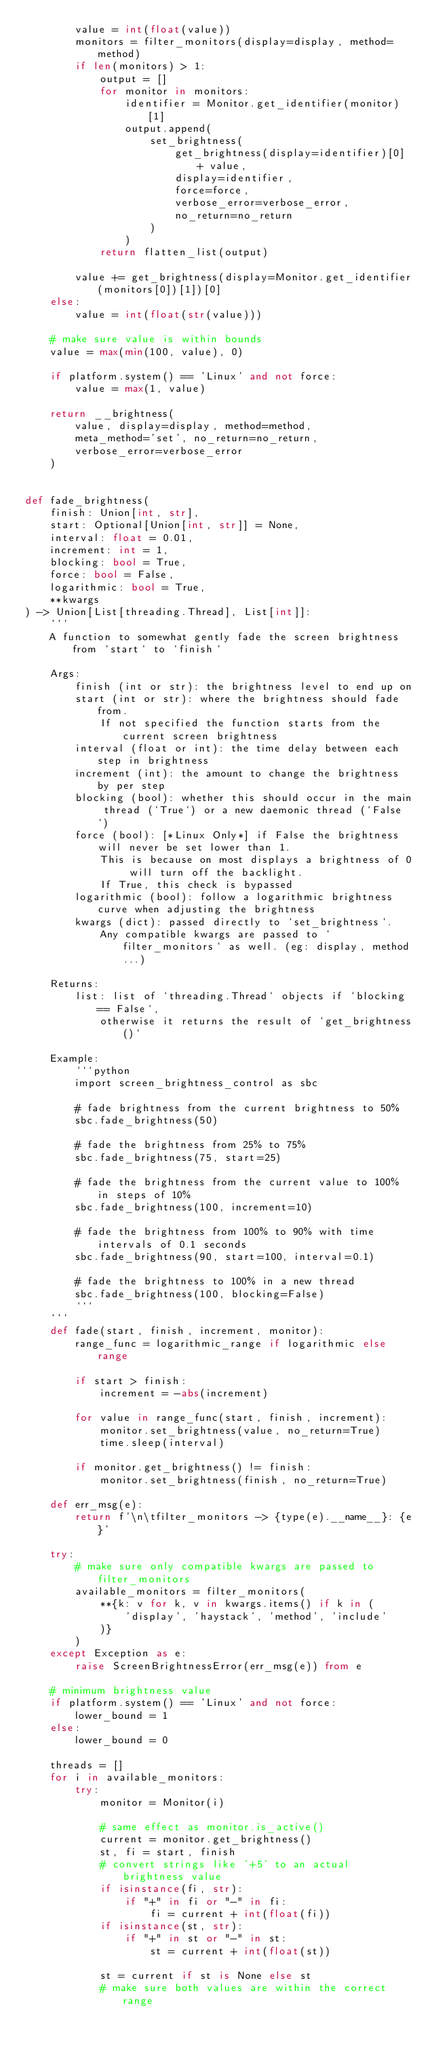<code> <loc_0><loc_0><loc_500><loc_500><_Python_>        value = int(float(value))
        monitors = filter_monitors(display=display, method=method)
        if len(monitors) > 1:
            output = []
            for monitor in monitors:
                identifier = Monitor.get_identifier(monitor)[1]
                output.append(
                    set_brightness(
                        get_brightness(display=identifier)[0] + value,
                        display=identifier,
                        force=force,
                        verbose_error=verbose_error,
                        no_return=no_return
                    )
                )
            return flatten_list(output)

        value += get_brightness(display=Monitor.get_identifier(monitors[0])[1])[0]
    else:
        value = int(float(str(value)))

    # make sure value is within bounds
    value = max(min(100, value), 0)

    if platform.system() == 'Linux' and not force:
        value = max(1, value)

    return __brightness(
        value, display=display, method=method,
        meta_method='set', no_return=no_return,
        verbose_error=verbose_error
    )


def fade_brightness(
    finish: Union[int, str],
    start: Optional[Union[int, str]] = None,
    interval: float = 0.01,
    increment: int = 1,
    blocking: bool = True,
    force: bool = False,
    logarithmic: bool = True,
    **kwargs
) -> Union[List[threading.Thread], List[int]]:
    '''
    A function to somewhat gently fade the screen brightness from `start` to `finish`

    Args:
        finish (int or str): the brightness level to end up on
        start (int or str): where the brightness should fade from.
            If not specified the function starts from the current screen brightness
        interval (float or int): the time delay between each step in brightness
        increment (int): the amount to change the brightness by per step
        blocking (bool): whether this should occur in the main thread (`True`) or a new daemonic thread (`False`)
        force (bool): [*Linux Only*] if False the brightness will never be set lower than 1.
            This is because on most displays a brightness of 0 will turn off the backlight.
            If True, this check is bypassed
        logarithmic (bool): follow a logarithmic brightness curve when adjusting the brightness
        kwargs (dict): passed directly to `set_brightness`.
            Any compatible kwargs are passed to `filter_monitors` as well. (eg: display, method...)

    Returns:
        list: list of `threading.Thread` objects if `blocking == False`,
            otherwise it returns the result of `get_brightness()`

    Example:
        ```python
        import screen_brightness_control as sbc

        # fade brightness from the current brightness to 50%
        sbc.fade_brightness(50)

        # fade the brightness from 25% to 75%
        sbc.fade_brightness(75, start=25)

        # fade the brightness from the current value to 100% in steps of 10%
        sbc.fade_brightness(100, increment=10)

        # fade the brightness from 100% to 90% with time intervals of 0.1 seconds
        sbc.fade_brightness(90, start=100, interval=0.1)

        # fade the brightness to 100% in a new thread
        sbc.fade_brightness(100, blocking=False)
        ```
    '''
    def fade(start, finish, increment, monitor):
        range_func = logarithmic_range if logarithmic else range

        if start > finish:
            increment = -abs(increment)

        for value in range_func(start, finish, increment):
            monitor.set_brightness(value, no_return=True)
            time.sleep(interval)

        if monitor.get_brightness() != finish:
            monitor.set_brightness(finish, no_return=True)

    def err_msg(e):
        return f'\n\tfilter_monitors -> {type(e).__name__}: {e}'

    try:
        # make sure only compatible kwargs are passed to filter_monitors
        available_monitors = filter_monitors(
            **{k: v for k, v in kwargs.items() if k in (
                'display', 'haystack', 'method', 'include'
            )}
        )
    except Exception as e:
        raise ScreenBrightnessError(err_msg(e)) from e

    # minimum brightness value
    if platform.system() == 'Linux' and not force:
        lower_bound = 1
    else:
        lower_bound = 0

    threads = []
    for i in available_monitors:
        try:
            monitor = Monitor(i)

            # same effect as monitor.is_active()
            current = monitor.get_brightness()
            st, fi = start, finish
            # convert strings like '+5' to an actual brightness value
            if isinstance(fi, str):
                if "+" in fi or "-" in fi:
                    fi = current + int(float(fi))
            if isinstance(st, str):
                if "+" in st or "-" in st:
                    st = current + int(float(st))

            st = current if st is None else st
            # make sure both values are within the correct range</code> 